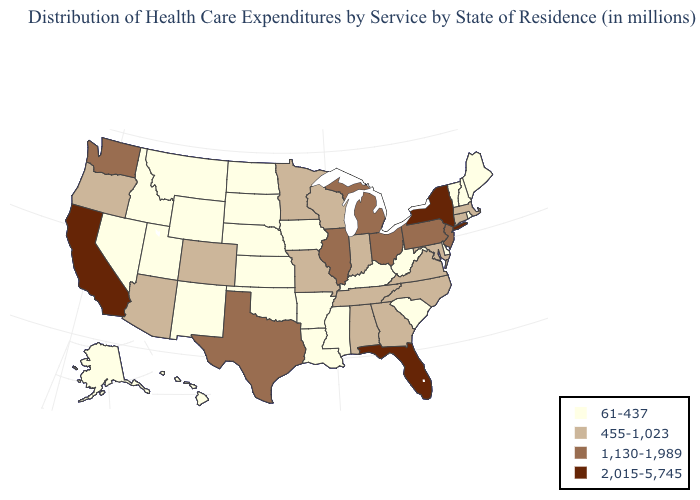Does California have the highest value in the USA?
Keep it brief. Yes. Name the states that have a value in the range 2,015-5,745?
Write a very short answer. California, Florida, New York. What is the value of Louisiana?
Give a very brief answer. 61-437. Name the states that have a value in the range 61-437?
Concise answer only. Alaska, Arkansas, Delaware, Hawaii, Idaho, Iowa, Kansas, Kentucky, Louisiana, Maine, Mississippi, Montana, Nebraska, Nevada, New Hampshire, New Mexico, North Dakota, Oklahoma, Rhode Island, South Carolina, South Dakota, Utah, Vermont, West Virginia, Wyoming. What is the value of Georgia?
Concise answer only. 455-1,023. What is the value of Utah?
Be succinct. 61-437. What is the lowest value in the Northeast?
Keep it brief. 61-437. Which states have the highest value in the USA?
Write a very short answer. California, Florida, New York. Name the states that have a value in the range 1,130-1,989?
Give a very brief answer. Illinois, Michigan, New Jersey, Ohio, Pennsylvania, Texas, Washington. Name the states that have a value in the range 61-437?
Give a very brief answer. Alaska, Arkansas, Delaware, Hawaii, Idaho, Iowa, Kansas, Kentucky, Louisiana, Maine, Mississippi, Montana, Nebraska, Nevada, New Hampshire, New Mexico, North Dakota, Oklahoma, Rhode Island, South Carolina, South Dakota, Utah, Vermont, West Virginia, Wyoming. Among the states that border Delaware , does New Jersey have the highest value?
Give a very brief answer. Yes. Among the states that border Massachusetts , which have the lowest value?
Be succinct. New Hampshire, Rhode Island, Vermont. Name the states that have a value in the range 455-1,023?
Answer briefly. Alabama, Arizona, Colorado, Connecticut, Georgia, Indiana, Maryland, Massachusetts, Minnesota, Missouri, North Carolina, Oregon, Tennessee, Virginia, Wisconsin. What is the value of Wyoming?
Be succinct. 61-437. Does the first symbol in the legend represent the smallest category?
Keep it brief. Yes. 